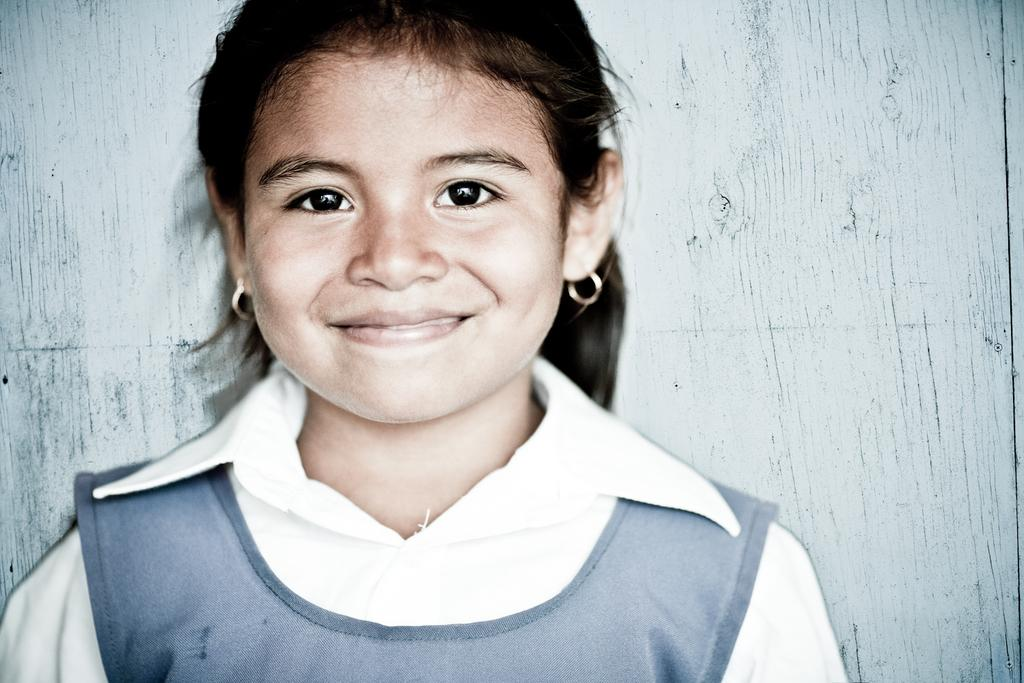Who or what is present in the image? There is a person in the image. What is the person wearing? The person is wearing a gray and white color dress. Can you describe the background of the image? The background of the image is ash colored. What type of brass instrument is the person playing in the image? There is no brass instrument present in the image; the person is simply wearing a gray and white color dress in an ash-colored background. 